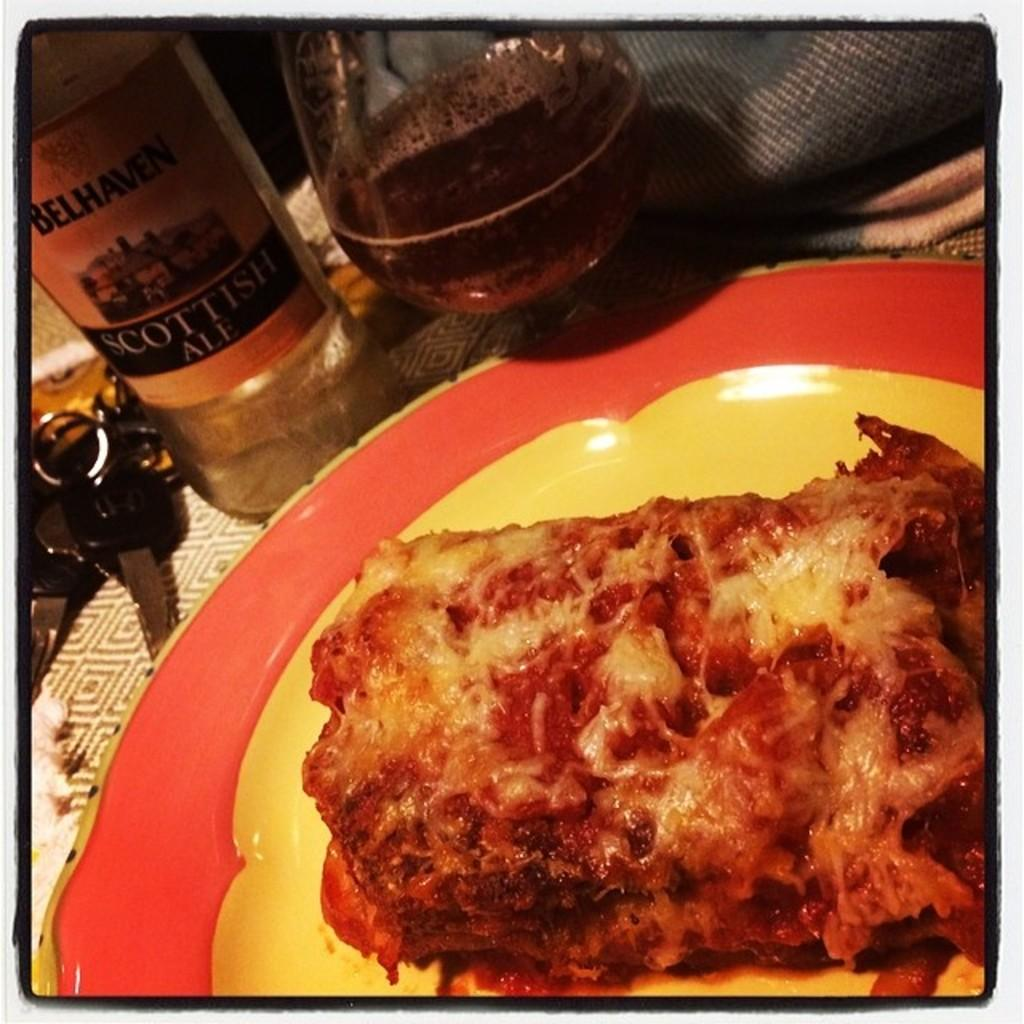<image>
Give a short and clear explanation of the subsequent image. A bottle of Scottish Ale is sitting beside a plate on a table. 